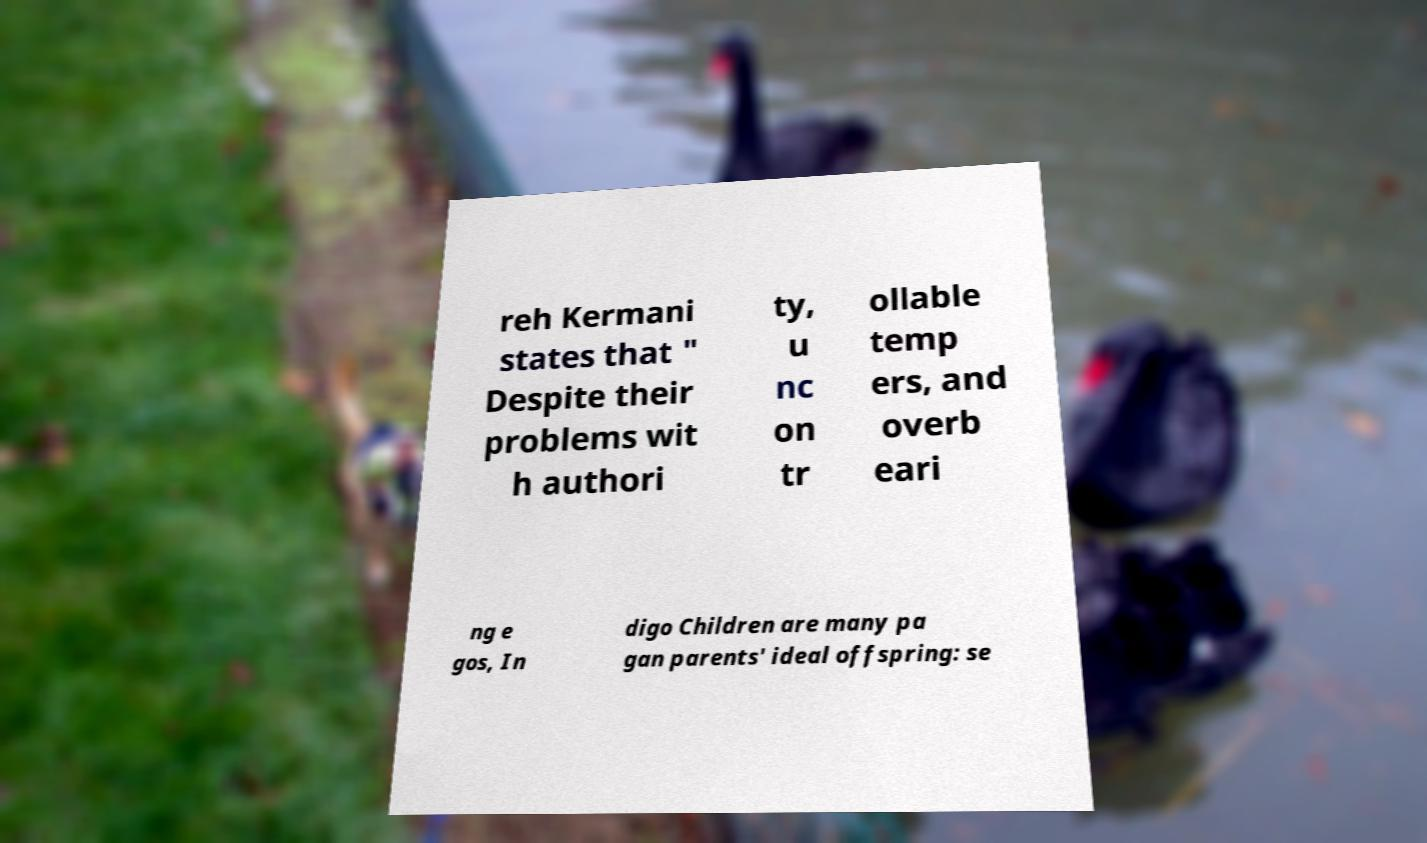Can you read and provide the text displayed in the image?This photo seems to have some interesting text. Can you extract and type it out for me? reh Kermani states that " Despite their problems wit h authori ty, u nc on tr ollable temp ers, and overb eari ng e gos, In digo Children are many pa gan parents' ideal offspring: se 